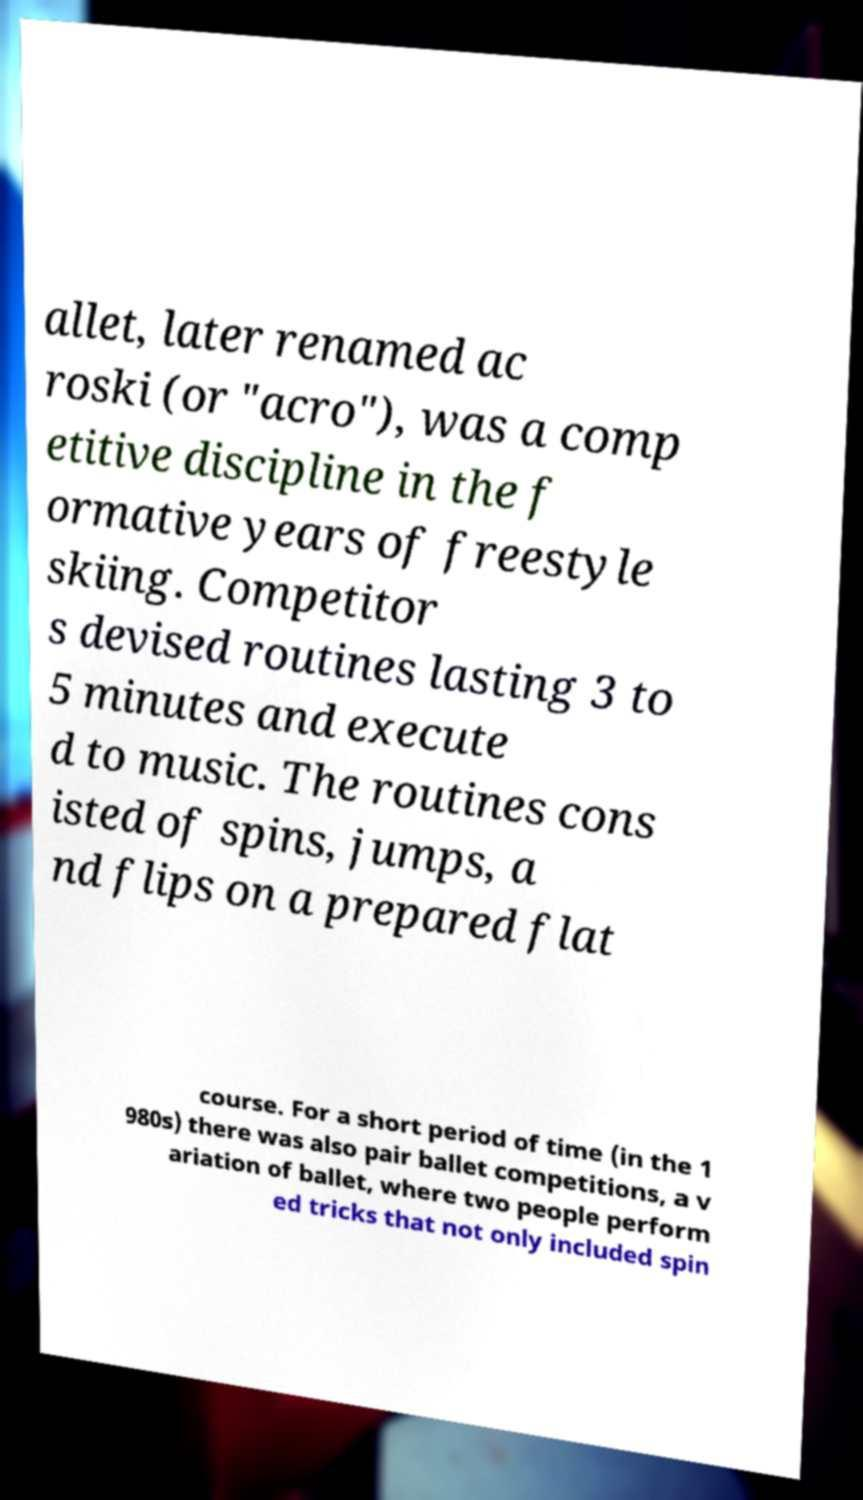Please identify and transcribe the text found in this image. allet, later renamed ac roski (or "acro"), was a comp etitive discipline in the f ormative years of freestyle skiing. Competitor s devised routines lasting 3 to 5 minutes and execute d to music. The routines cons isted of spins, jumps, a nd flips on a prepared flat course. For a short period of time (in the 1 980s) there was also pair ballet competitions, a v ariation of ballet, where two people perform ed tricks that not only included spin 